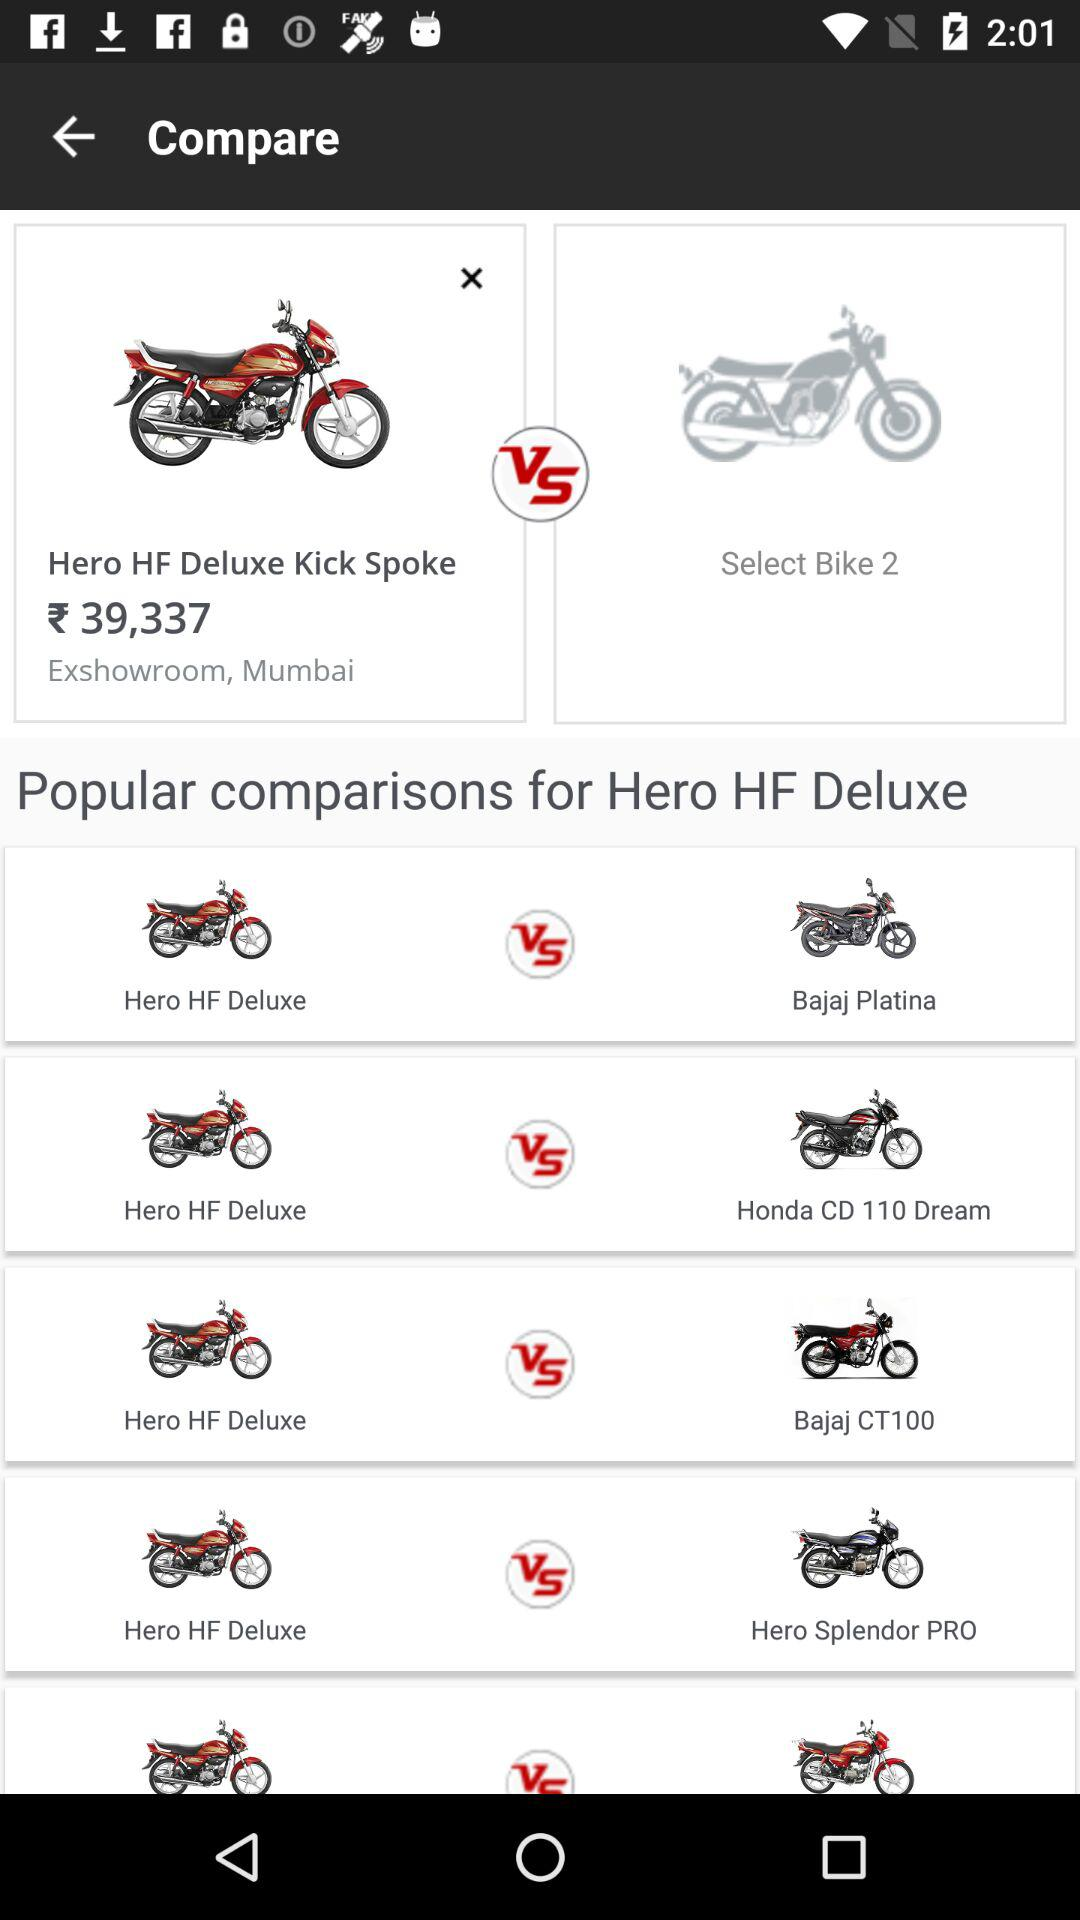What is the given location? The given location is Mumbai. 